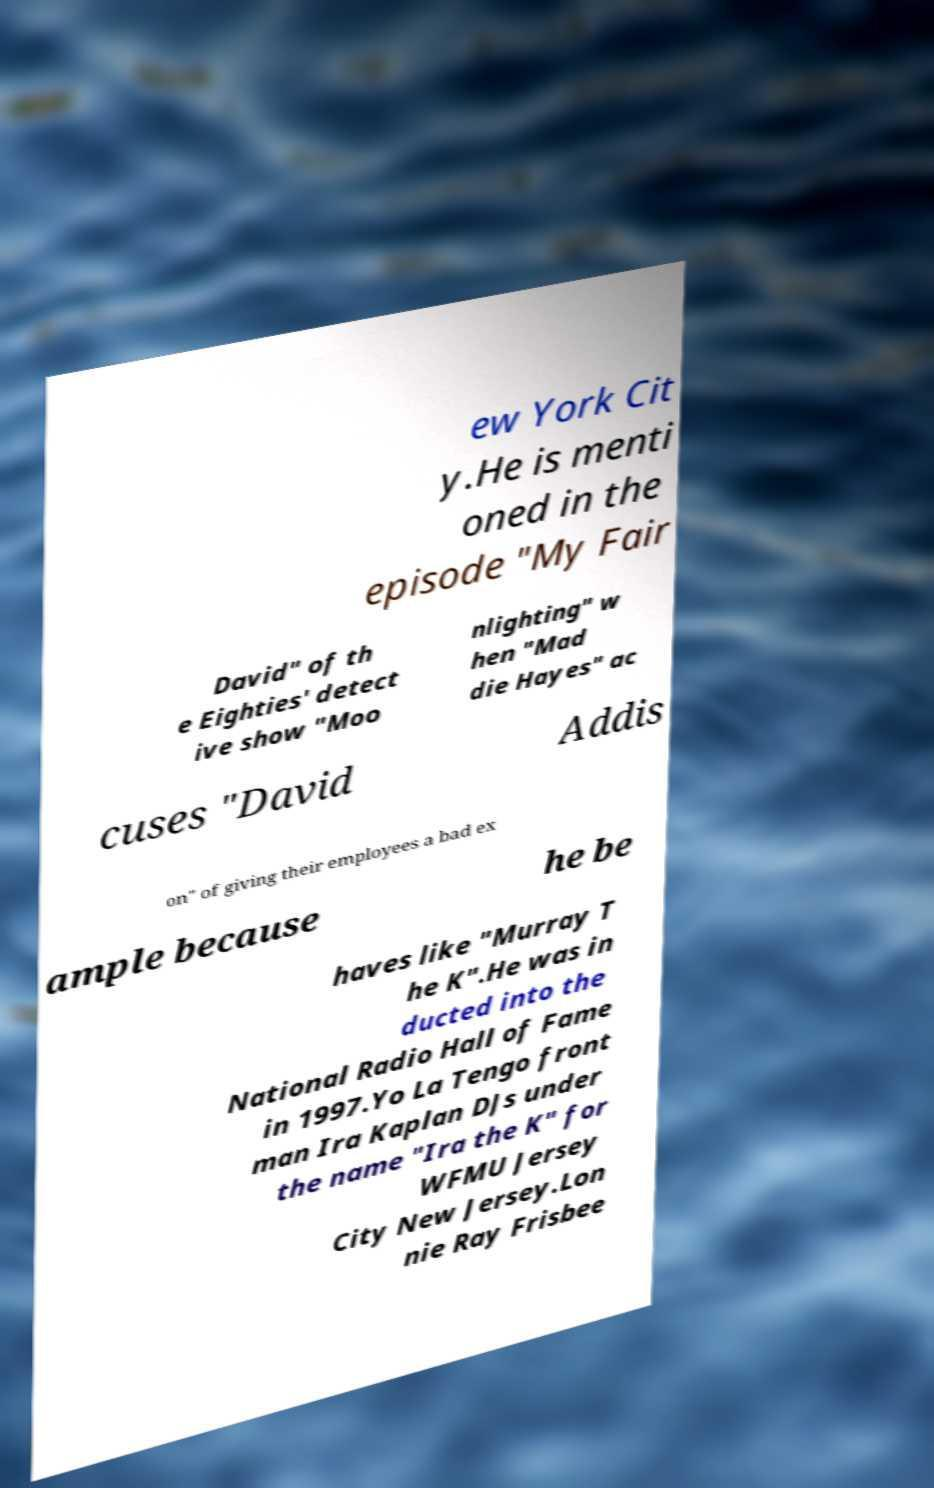There's text embedded in this image that I need extracted. Can you transcribe it verbatim? ew York Cit y.He is menti oned in the episode "My Fair David" of th e Eighties' detect ive show "Moo nlighting" w hen "Mad die Hayes" ac cuses "David Addis on" of giving their employees a bad ex ample because he be haves like "Murray T he K".He was in ducted into the National Radio Hall of Fame in 1997.Yo La Tengo front man Ira Kaplan DJs under the name "Ira the K" for WFMU Jersey City New Jersey.Lon nie Ray Frisbee 